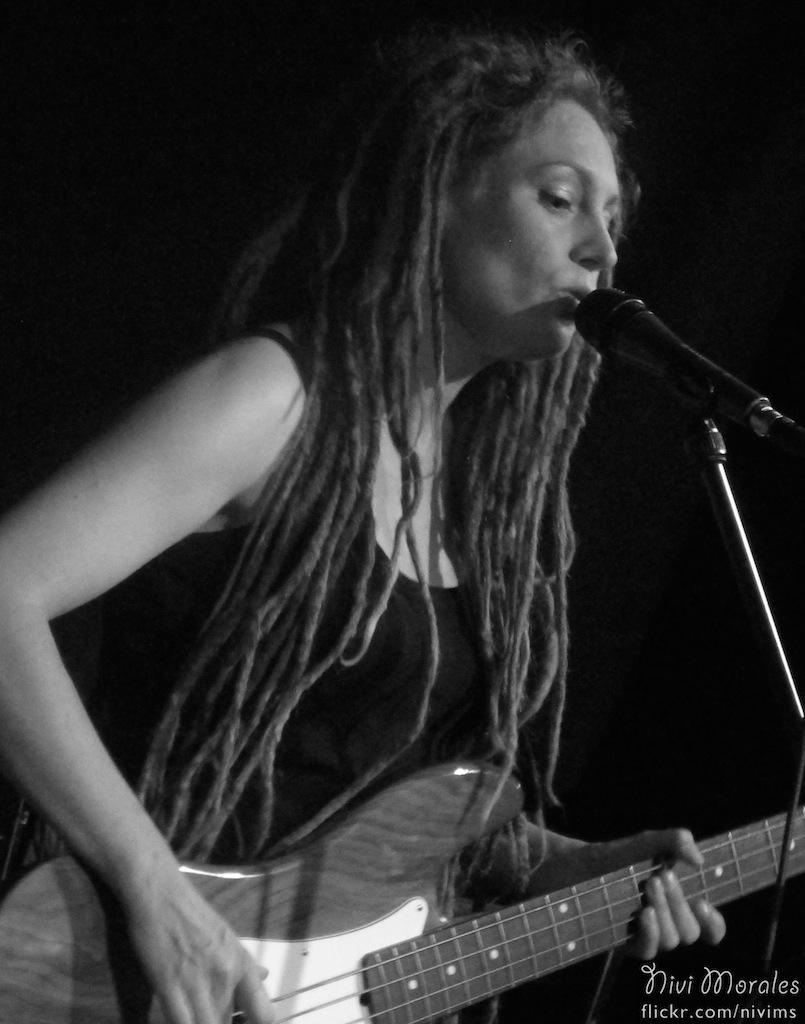Who is the main subject in the image? There is a lady in the image. What is the lady doing in the image? The lady is standing in the image. What object is the lady holding in her hand? The lady is holding a guitar in her hand. What is the purpose of the object in front of the lady? There is a microphone (mic) in front of her, which is likely used for amplifying her voice while singing or speaking. What type of chain is the lady wearing in the image? There is no chain visible on the lady in the image. 